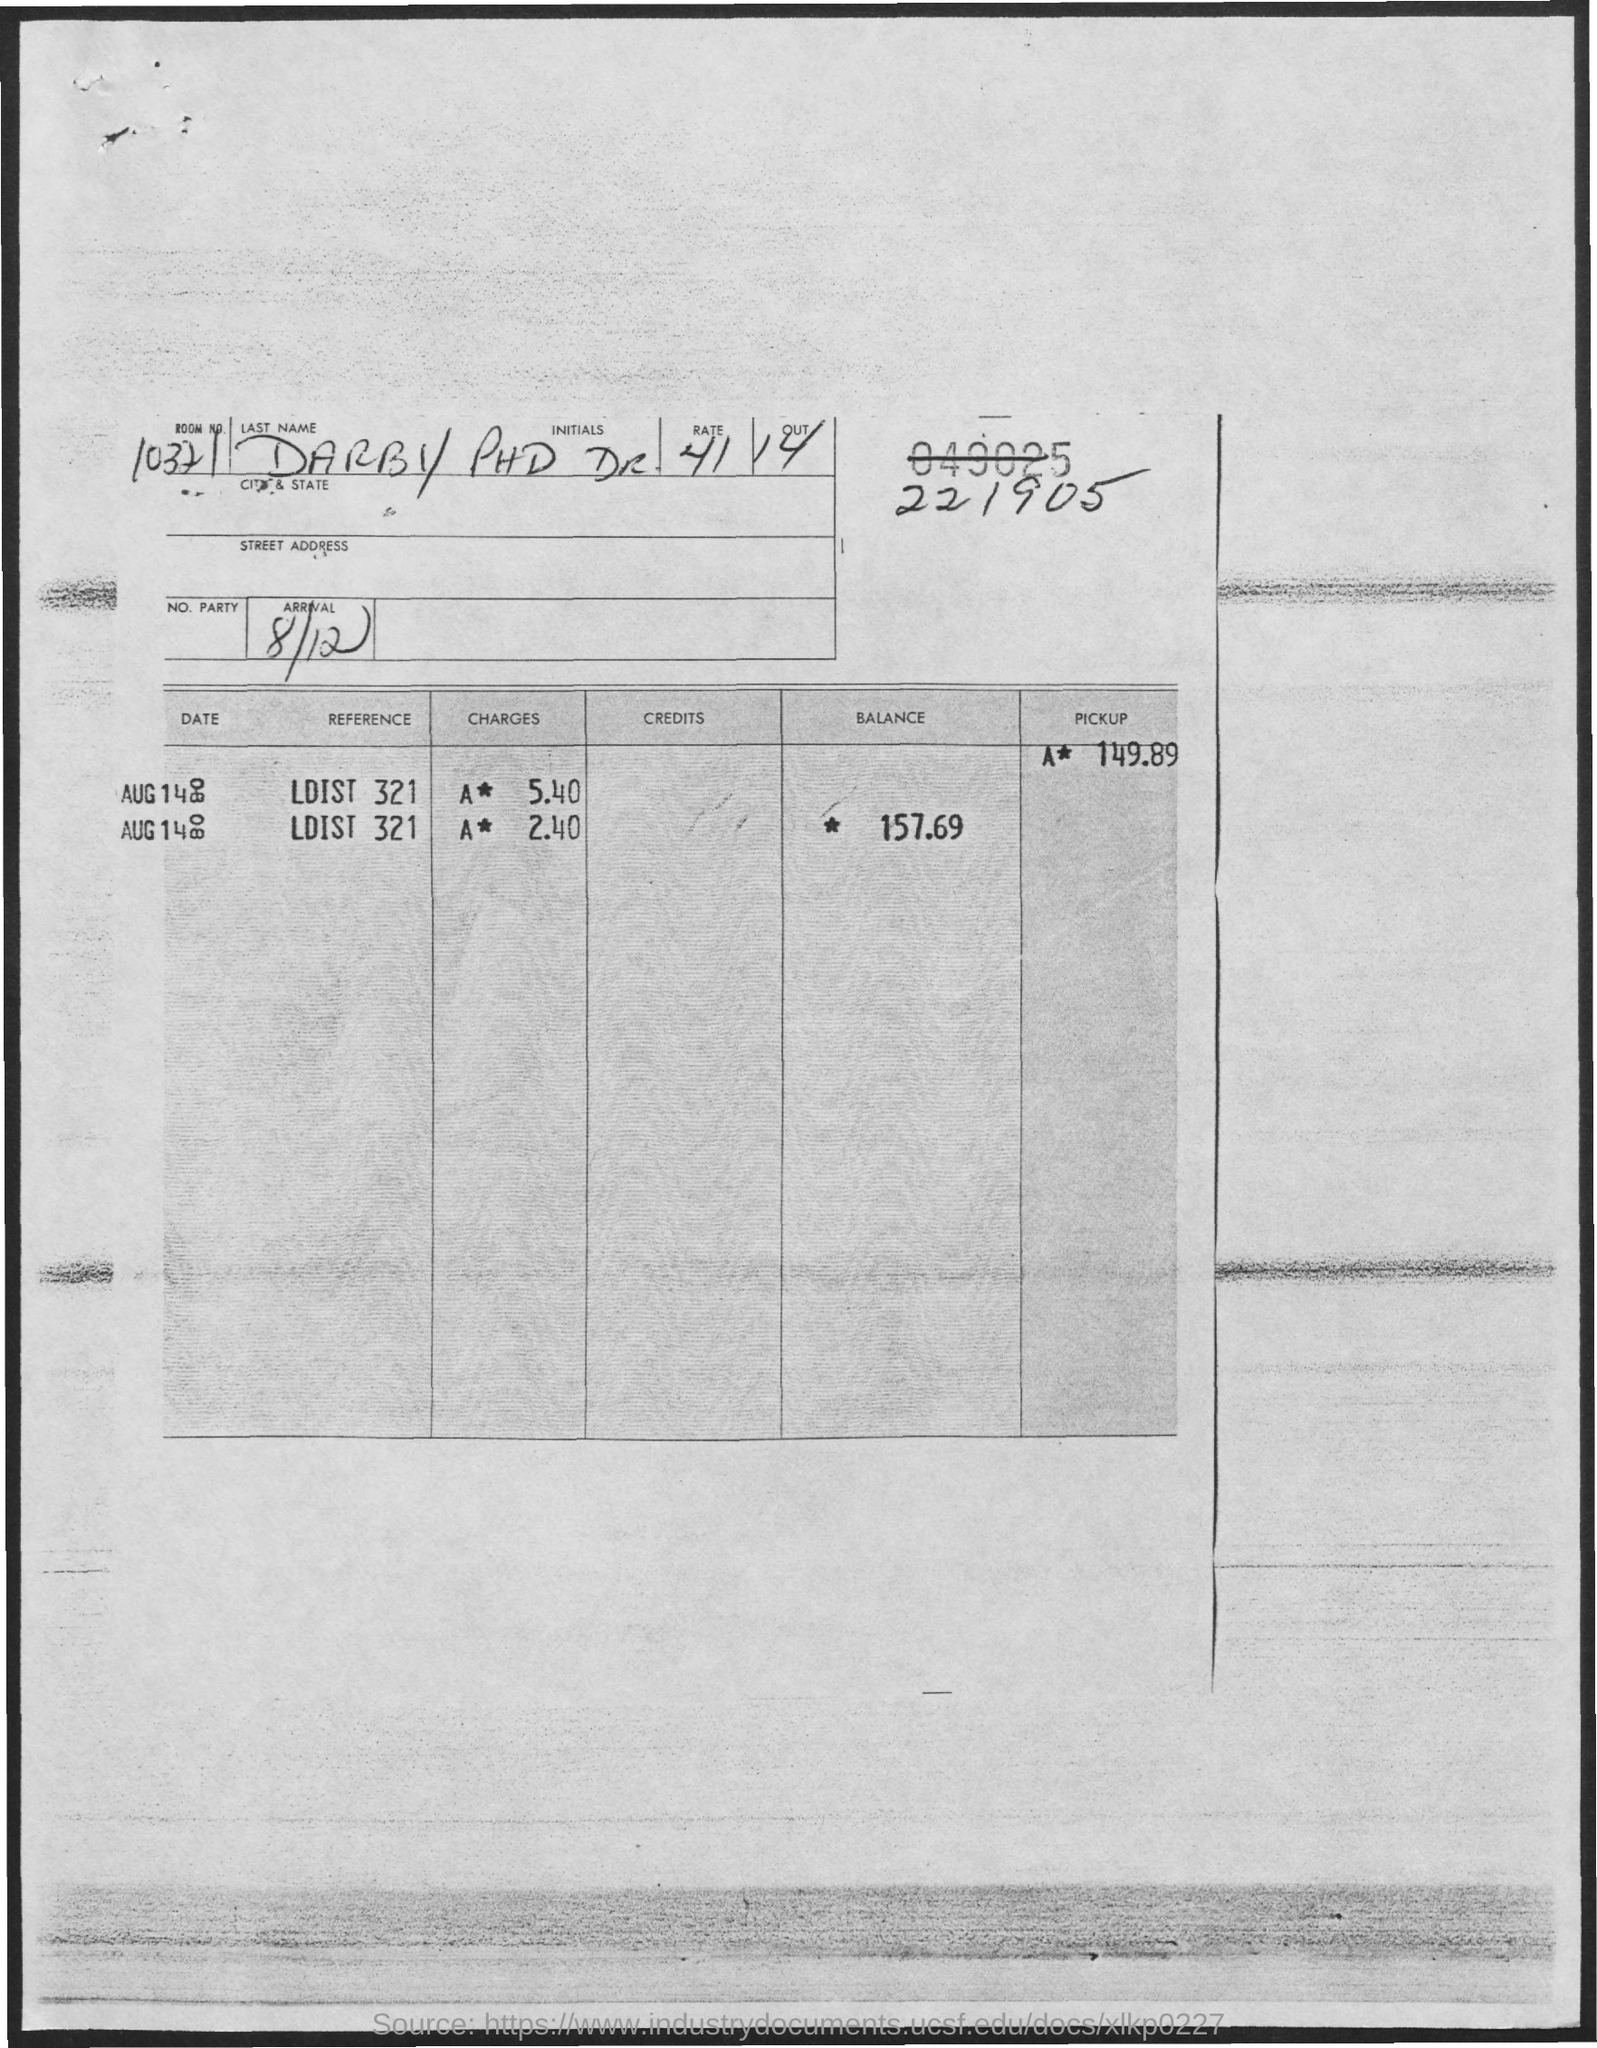What is the arrival date ( day and month)?
Keep it short and to the point. 8/12. What is the date of arrival?
Give a very brief answer. 8/12. What is the rate?
Your answer should be very brief. 41. 